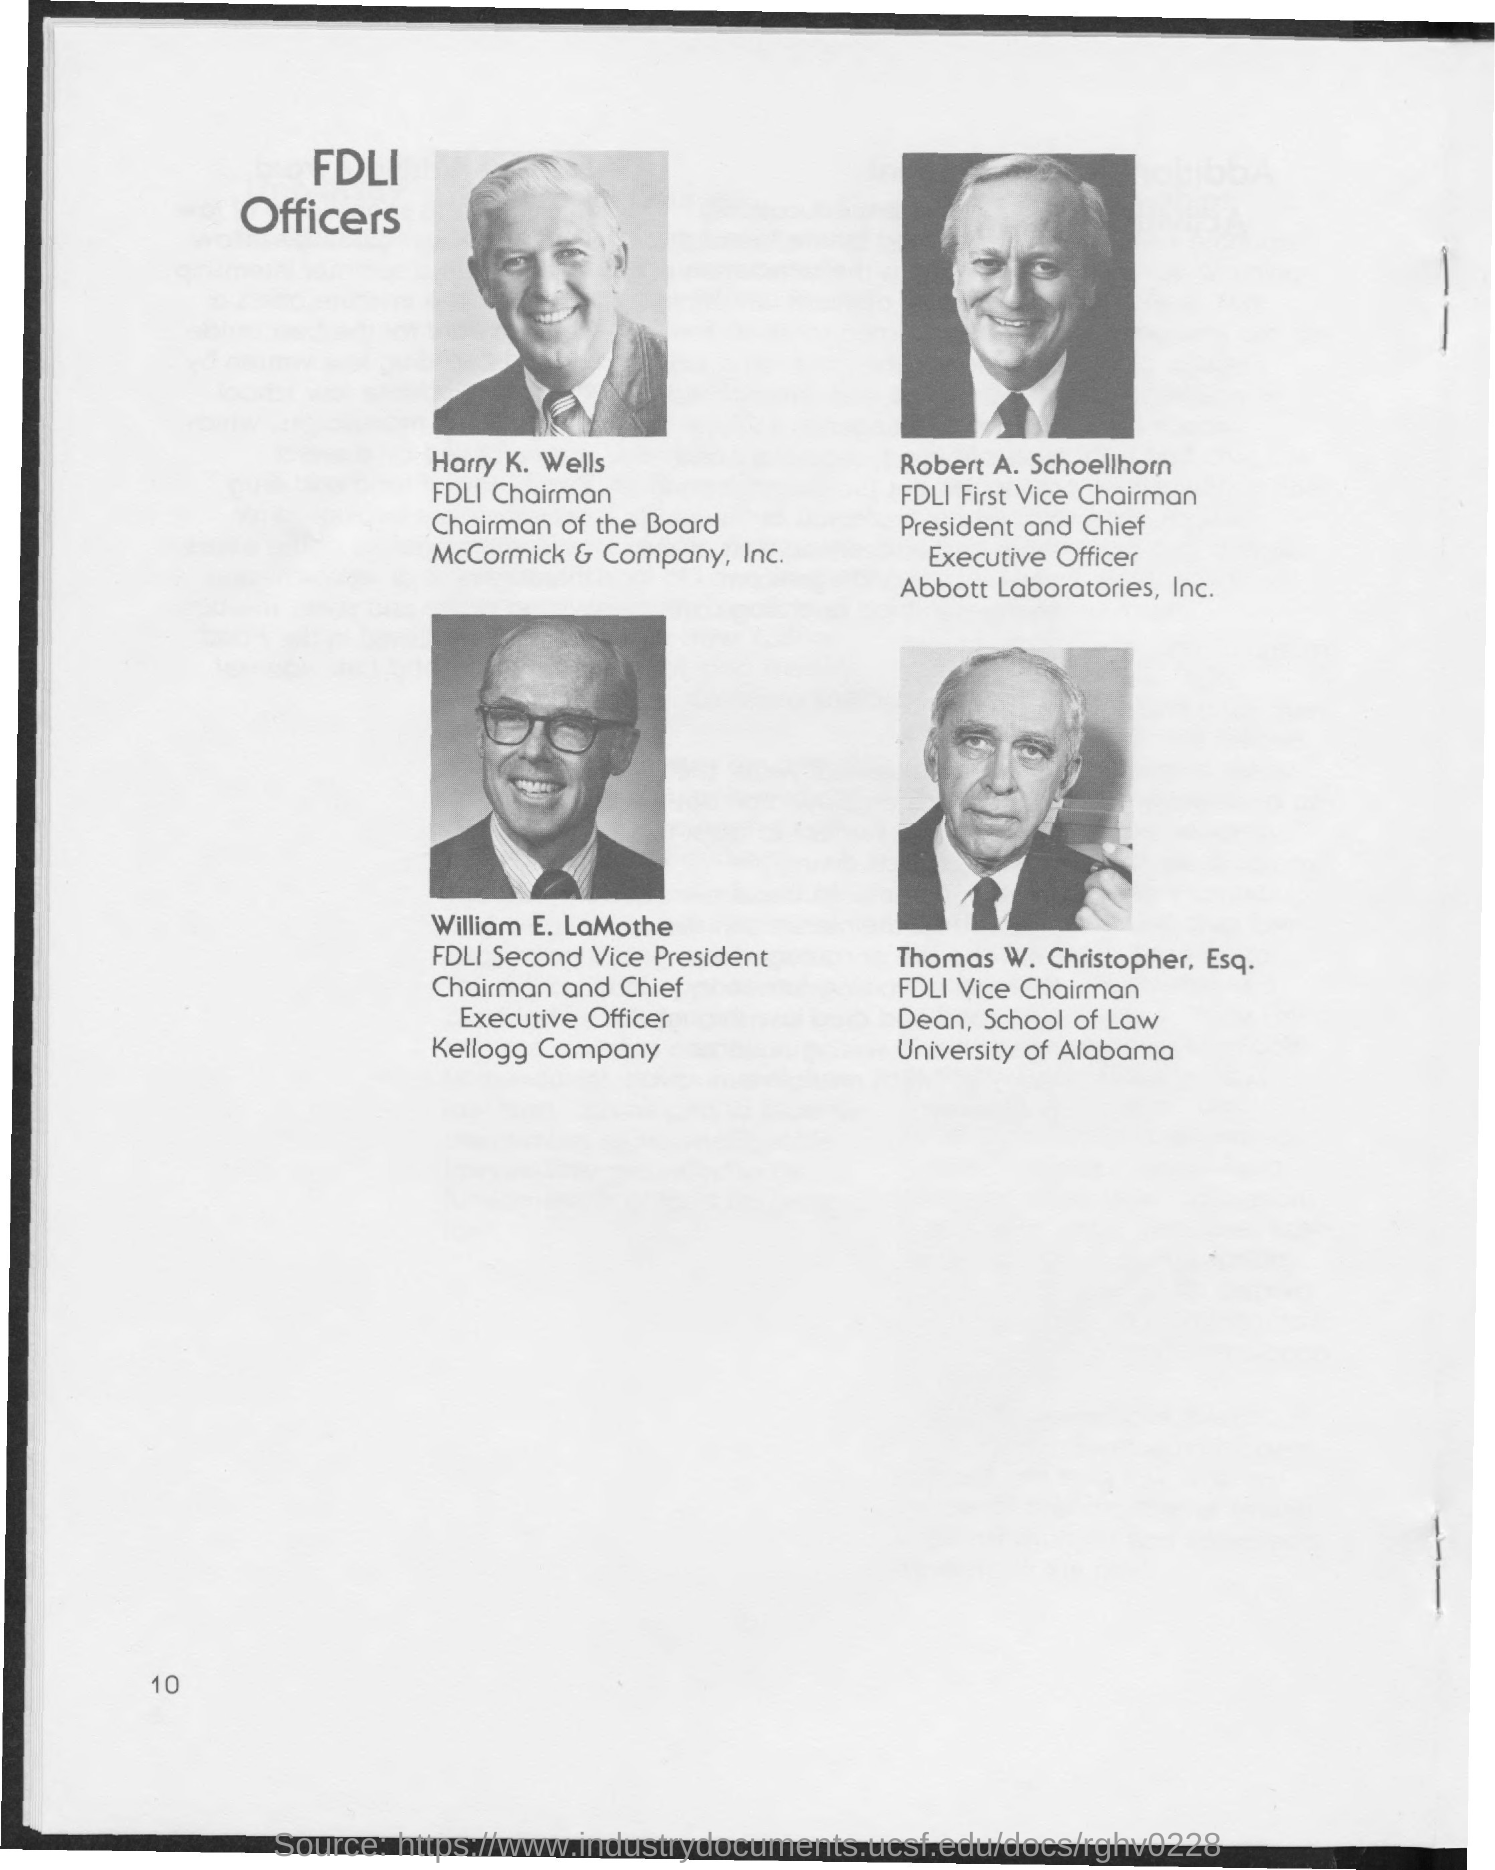Draw attention to some important aspects in this diagram. The page number is 10. William E. LaMothe is the second vice-president of FDLI (Food and Drug Law Institute). The FDLI Chairman is Harry K. Wells. The title of the document is 'FDLI Officers.' Thomas W. Christopher, Esq. is the vice-chairman of FDLI (Food and Drug Law Institute). 